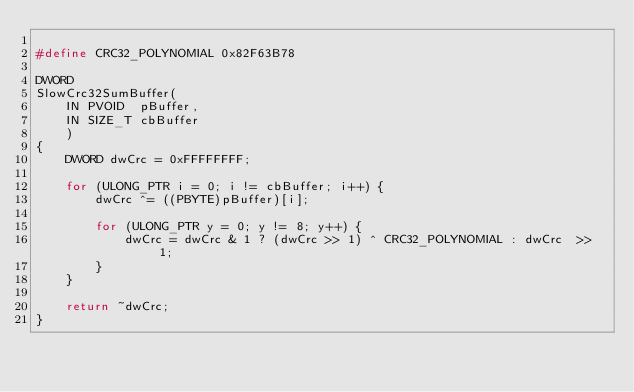Convert code to text. <code><loc_0><loc_0><loc_500><loc_500><_C_>
#define CRC32_POLYNOMIAL 0x82F63B78

DWORD
SlowCrc32SumBuffer(
    IN PVOID  pBuffer,
    IN SIZE_T cbBuffer
    )
{
    DWORD dwCrc = 0xFFFFFFFF;

    for (ULONG_PTR i = 0; i != cbBuffer; i++) {
        dwCrc ^= ((PBYTE)pBuffer)[i];

        for (ULONG_PTR y = 0; y != 8; y++) {
            dwCrc = dwCrc & 1 ? (dwCrc >> 1) ^ CRC32_POLYNOMIAL : dwCrc  >> 1;
        }
    }

    return ~dwCrc;
}
</code> 